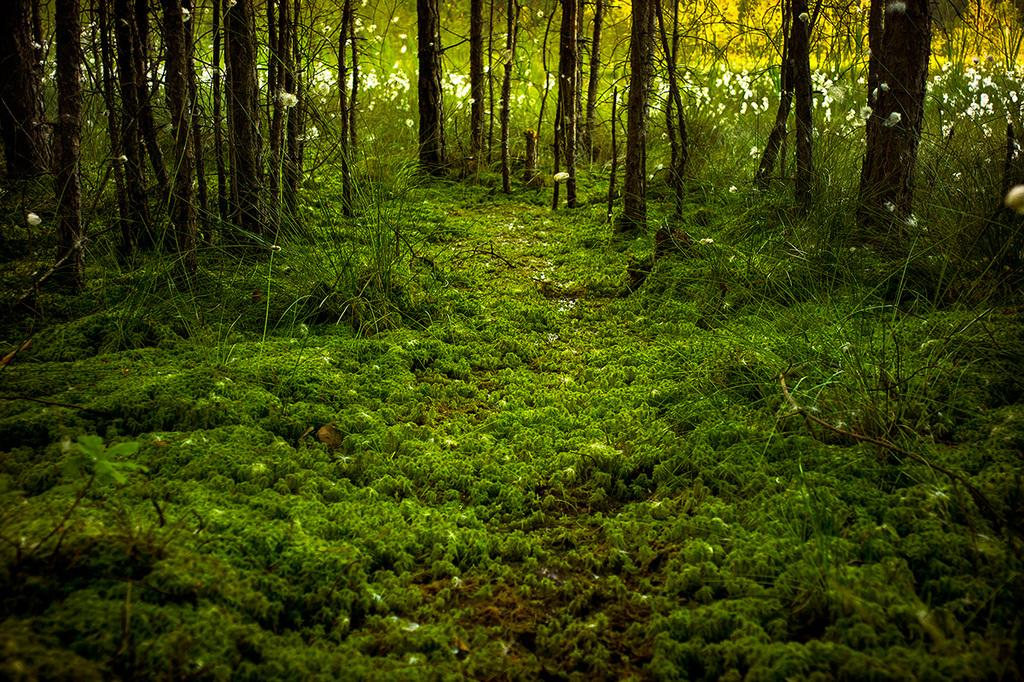What type of vegetation is present in the image? There are a lot of plants in the image. Can you describe the ground in the image? There is thick grass in the image. How would you characterize the overall appearance of the image? The scenery in the image is beautiful. What type of meat can be seen hanging from the trees in the image? There is no meat present in the image; it features a lot of plants and thick grass. 